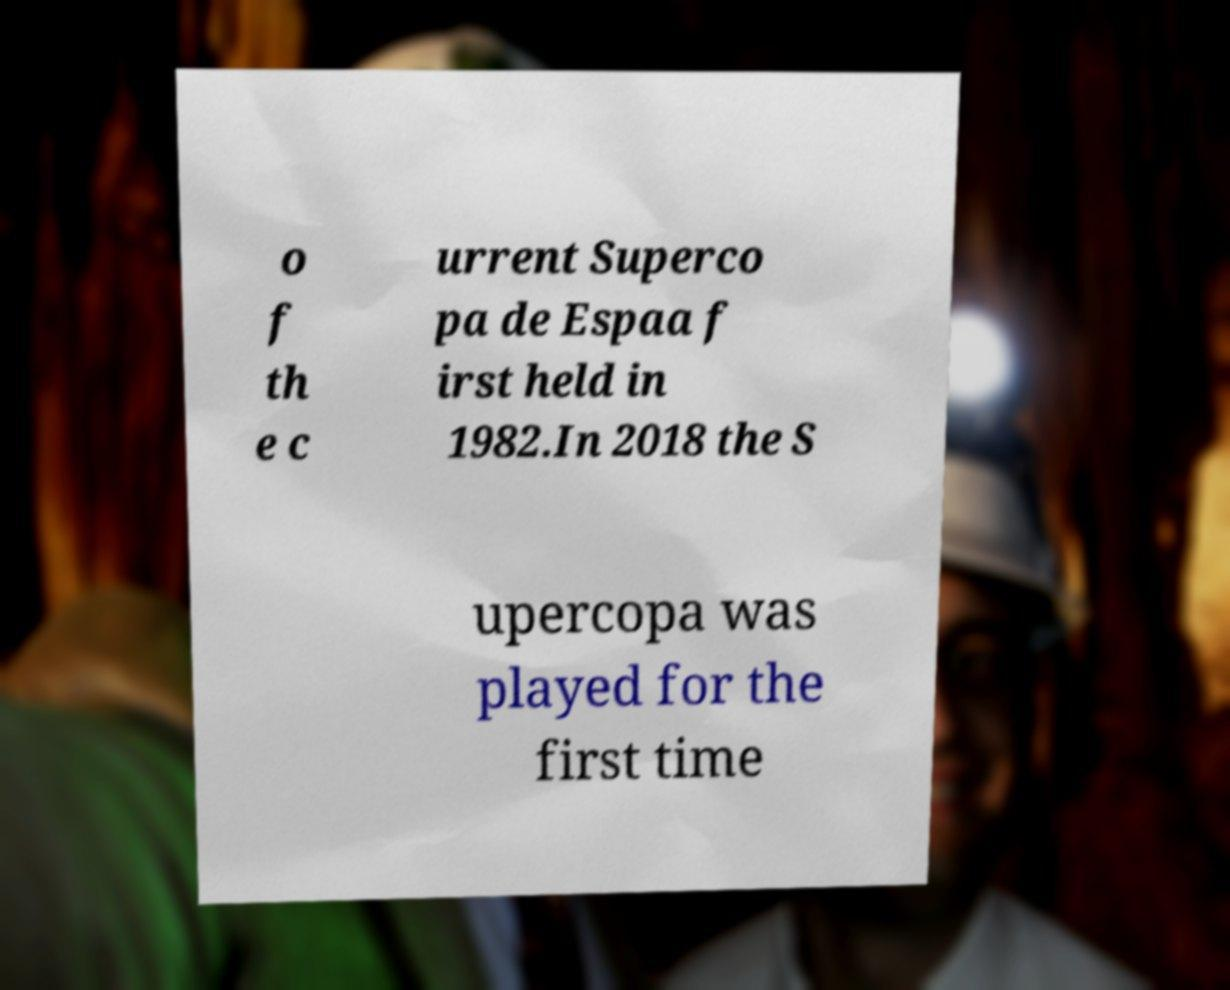Could you assist in decoding the text presented in this image and type it out clearly? o f th e c urrent Superco pa de Espaa f irst held in 1982.In 2018 the S upercopa was played for the first time 